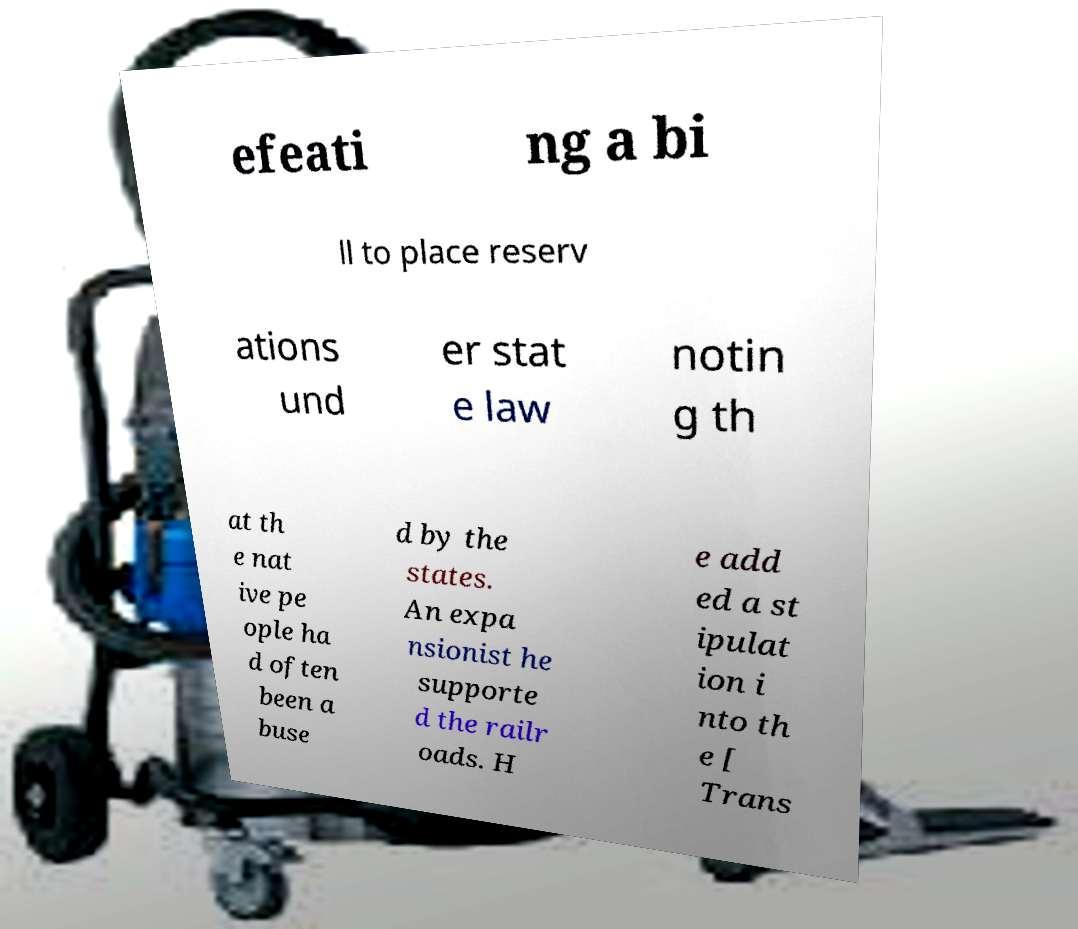Please identify and transcribe the text found in this image. efeati ng a bi ll to place reserv ations und er stat e law notin g th at th e nat ive pe ople ha d often been a buse d by the states. An expa nsionist he supporte d the railr oads. H e add ed a st ipulat ion i nto th e [ Trans 